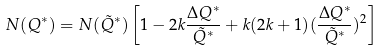<formula> <loc_0><loc_0><loc_500><loc_500>N ( Q ^ { * } ) = N ( \tilde { Q } ^ { * } ) \left [ 1 - 2 k \frac { \Delta Q ^ { * } } { \tilde { Q } ^ { * } } + k ( 2 k + 1 ) ( \frac { \Delta Q ^ { * } } { \tilde { Q } ^ { * } } ) ^ { 2 } \right ]</formula> 